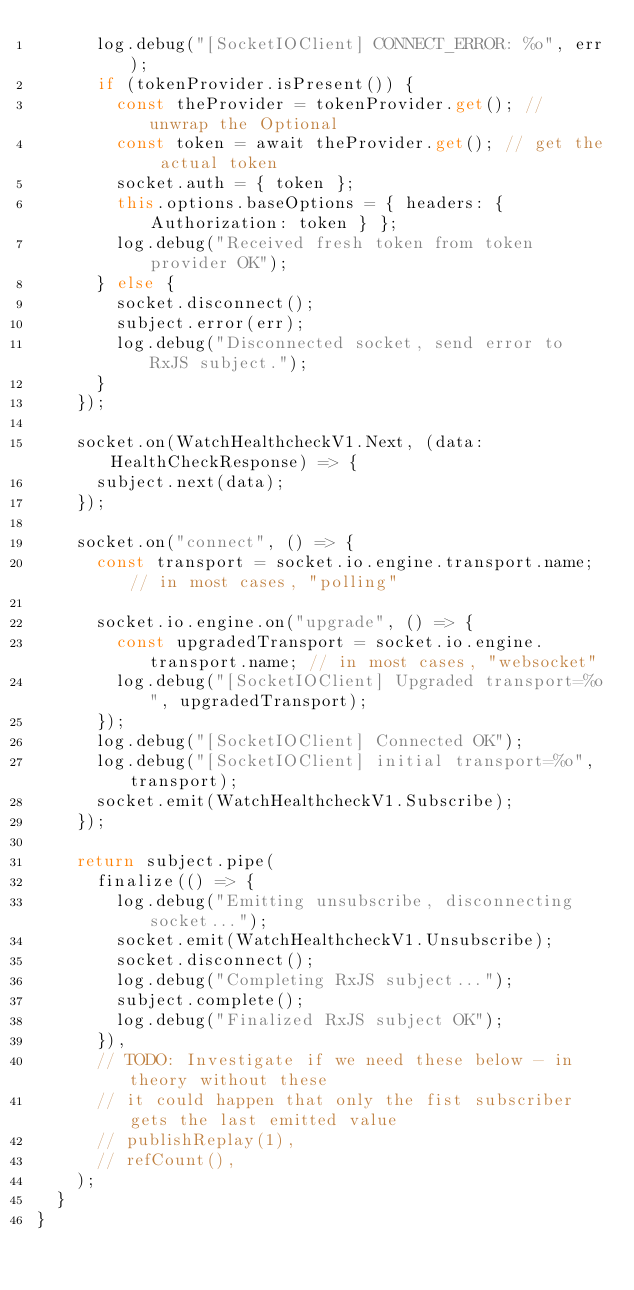Convert code to text. <code><loc_0><loc_0><loc_500><loc_500><_TypeScript_>      log.debug("[SocketIOClient] CONNECT_ERROR: %o", err);
      if (tokenProvider.isPresent()) {
        const theProvider = tokenProvider.get(); // unwrap the Optional
        const token = await theProvider.get(); // get the actual token
        socket.auth = { token };
        this.options.baseOptions = { headers: { Authorization: token } };
        log.debug("Received fresh token from token provider OK");
      } else {
        socket.disconnect();
        subject.error(err);
        log.debug("Disconnected socket, send error to RxJS subject.");
      }
    });

    socket.on(WatchHealthcheckV1.Next, (data: HealthCheckResponse) => {
      subject.next(data);
    });

    socket.on("connect", () => {
      const transport = socket.io.engine.transport.name; // in most cases, "polling"

      socket.io.engine.on("upgrade", () => {
        const upgradedTransport = socket.io.engine.transport.name; // in most cases, "websocket"
        log.debug("[SocketIOClient] Upgraded transport=%o", upgradedTransport);
      });
      log.debug("[SocketIOClient] Connected OK");
      log.debug("[SocketIOClient] initial transport=%o", transport);
      socket.emit(WatchHealthcheckV1.Subscribe);
    });

    return subject.pipe(
      finalize(() => {
        log.debug("Emitting unsubscribe, disconnecting socket...");
        socket.emit(WatchHealthcheckV1.Unsubscribe);
        socket.disconnect();
        log.debug("Completing RxJS subject...");
        subject.complete();
        log.debug("Finalized RxJS subject OK");
      }),
      // TODO: Investigate if we need these below - in theory without these
      // it could happen that only the fist subscriber gets the last emitted value
      // publishReplay(1),
      // refCount(),
    );
  }
}
</code> 